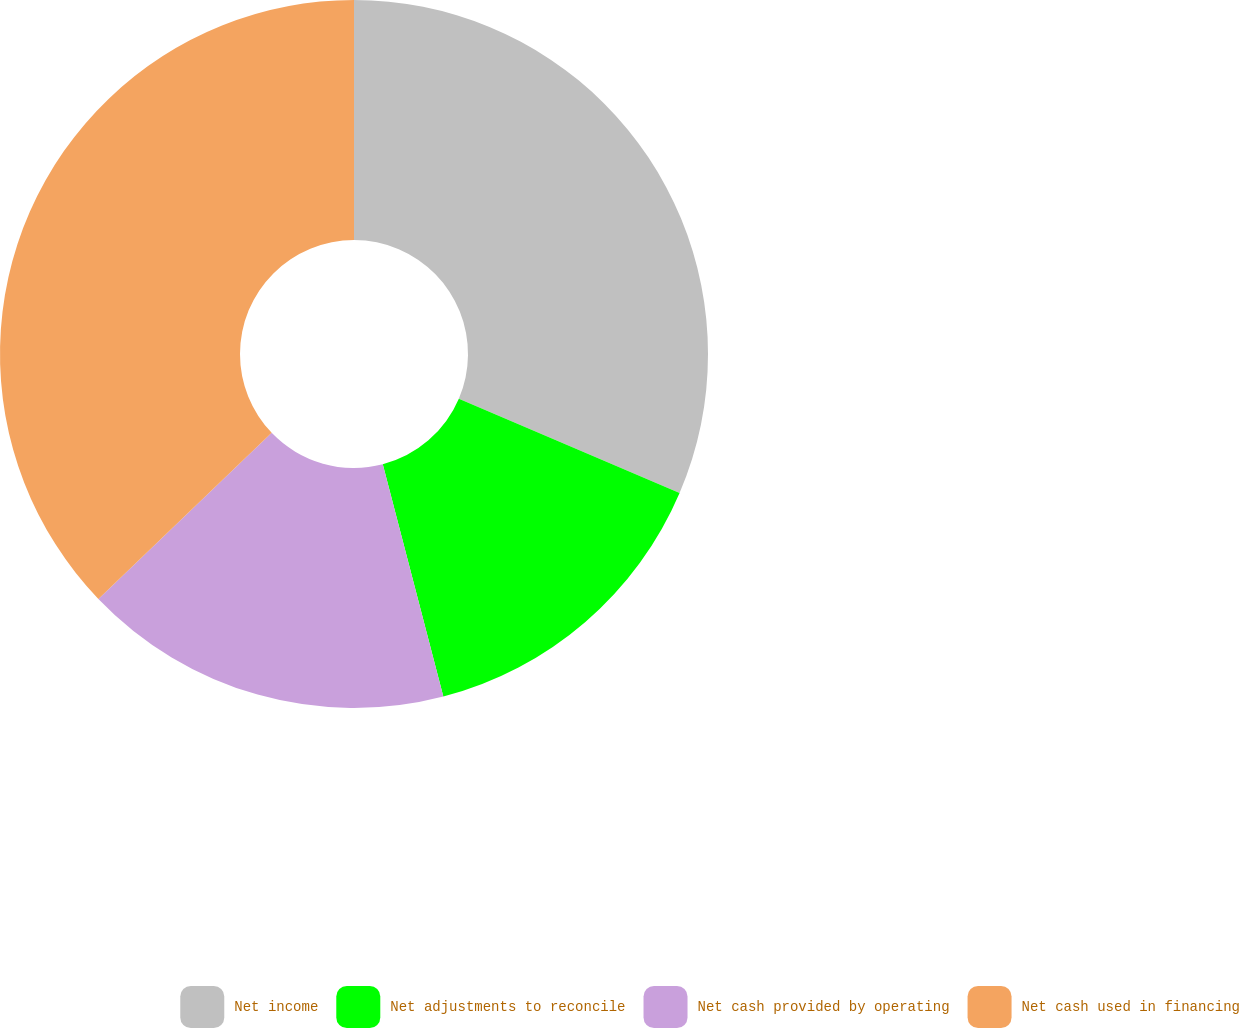Convert chart. <chart><loc_0><loc_0><loc_500><loc_500><pie_chart><fcel>Net income<fcel>Net adjustments to reconcile<fcel>Net cash provided by operating<fcel>Net cash used in financing<nl><fcel>31.42%<fcel>14.52%<fcel>16.9%<fcel>37.16%<nl></chart> 